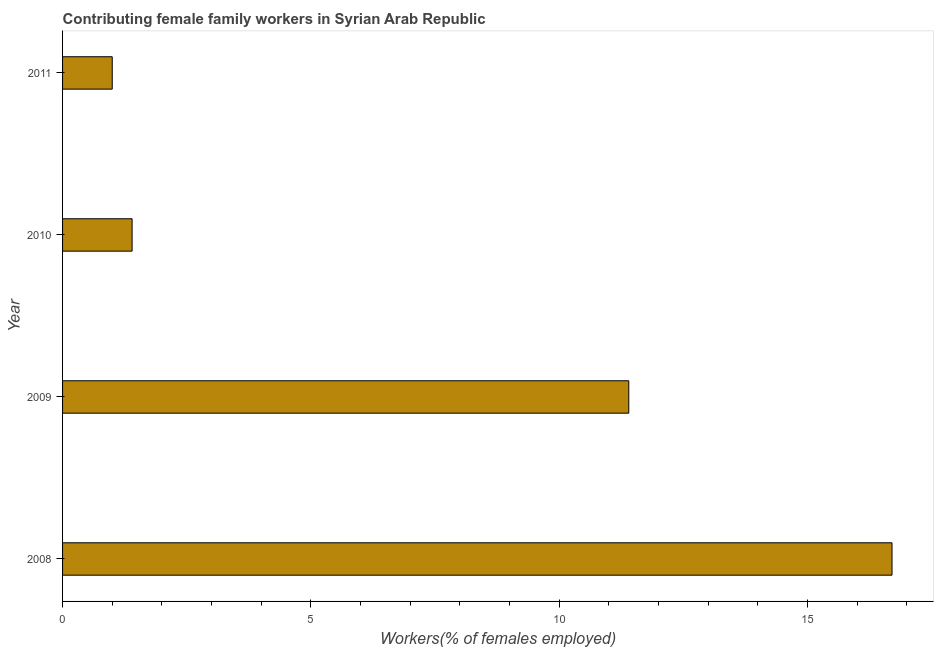Does the graph contain any zero values?
Provide a short and direct response. No. Does the graph contain grids?
Make the answer very short. No. What is the title of the graph?
Make the answer very short. Contributing female family workers in Syrian Arab Republic. What is the label or title of the X-axis?
Your answer should be very brief. Workers(% of females employed). What is the contributing female family workers in 2009?
Provide a short and direct response. 11.4. Across all years, what is the maximum contributing female family workers?
Ensure brevity in your answer.  16.7. What is the sum of the contributing female family workers?
Your answer should be compact. 30.5. What is the average contributing female family workers per year?
Your answer should be compact. 7.62. What is the median contributing female family workers?
Your response must be concise. 6.4. Do a majority of the years between 2008 and 2011 (inclusive) have contributing female family workers greater than 9 %?
Provide a succinct answer. No. What is the ratio of the contributing female family workers in 2009 to that in 2010?
Give a very brief answer. 8.14. Is the difference between the contributing female family workers in 2010 and 2011 greater than the difference between any two years?
Offer a terse response. No. Is the sum of the contributing female family workers in 2009 and 2011 greater than the maximum contributing female family workers across all years?
Provide a succinct answer. No. In how many years, is the contributing female family workers greater than the average contributing female family workers taken over all years?
Your response must be concise. 2. How many bars are there?
Give a very brief answer. 4. How many years are there in the graph?
Make the answer very short. 4. What is the difference between two consecutive major ticks on the X-axis?
Make the answer very short. 5. What is the Workers(% of females employed) of 2008?
Keep it short and to the point. 16.7. What is the Workers(% of females employed) of 2009?
Make the answer very short. 11.4. What is the Workers(% of females employed) in 2010?
Keep it short and to the point. 1.4. What is the difference between the Workers(% of females employed) in 2008 and 2010?
Your response must be concise. 15.3. What is the difference between the Workers(% of females employed) in 2008 and 2011?
Give a very brief answer. 15.7. What is the ratio of the Workers(% of females employed) in 2008 to that in 2009?
Provide a short and direct response. 1.47. What is the ratio of the Workers(% of females employed) in 2008 to that in 2010?
Keep it short and to the point. 11.93. What is the ratio of the Workers(% of females employed) in 2009 to that in 2010?
Offer a terse response. 8.14. 